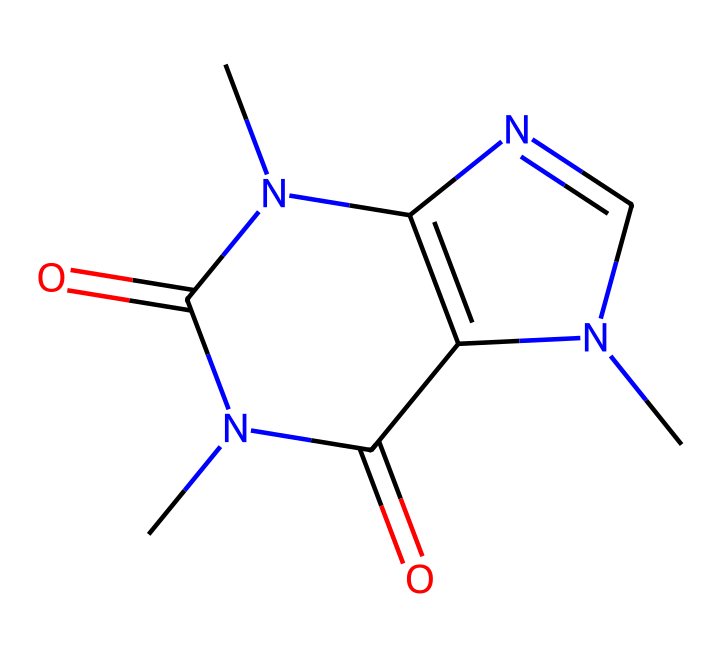What is the molecular formula of caffeine? By analyzing the SMILES representation, we can identify the constituent atoms. The structure indicates it has 8 carbon atoms (C), 10 hydrogen atoms (H), 4 nitrogen atoms (N), and 2 oxygen atoms (O), leading to the molecular formula C8H10N4O2.
Answer: C8H10N4O2 How many rings are present in the caffeine structure? The SMILES notation reveals that the molecular structure of caffeine contains two interconnected rings. This is characteristic of purine derivatives.
Answer: 2 What type of compound is caffeine classified as? Caffeine contains nitrogen atoms and exhibits properties typical of alkaloids. Alkaloids are compounds that often have significant physiological effects. The presence of nitrogen is a key indicator of this classification.
Answer: alkaloid How does caffeine primarily affect memory? Caffeine is known to enhance alertness and attention, which are critical for memory processing. It mainly acts as a stimulant by blocking adenosine receptors in the brain, thereby increasing dopamine levels, which improves cognitive function.
Answer: stimulant What functional groups are present in caffeine? Reviewing the SMILES structure, we can identify amine and carbonyl functional groups. The nitrogen atoms present indicate amine groups, and the carbonyl (C=O) indicates the presence of ketone or amide functionalities.
Answer: amine, carbonyl What is the impact of caffeine on adenosine receptors? Caffeine antagonizes adenosine receptors, particularly A1 and A2A subtypes. This antagonism leads to increased neuronal firing and release of neurotransmitters such as dopamine and norepinephrine, enhancing alertness and potentially memory performance.
Answer: antagonizes How many nitrogen atoms are found in the caffeine structure? The chemical structure as represented by the SMILES shows four nitrogen atoms, identifiable as part of the amine and imine functionalities. Count the nitrogen letters in the SMILES string to confirm this quantity.
Answer: 4 